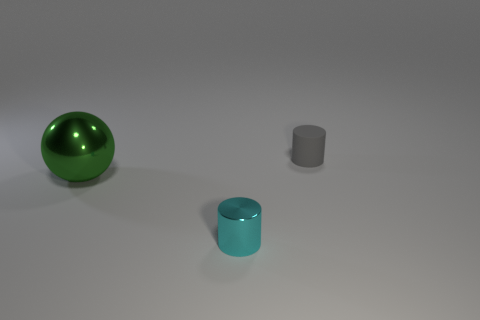Add 3 small cyan cylinders. How many objects exist? 6 Subtract 0 gray cubes. How many objects are left? 3 Subtract all cylinders. How many objects are left? 1 Subtract all yellow cylinders. Subtract all cyan blocks. How many cylinders are left? 2 Subtract all shiny cylinders. Subtract all large shiny objects. How many objects are left? 1 Add 1 tiny rubber objects. How many tiny rubber objects are left? 2 Add 3 big shiny spheres. How many big shiny spheres exist? 4 